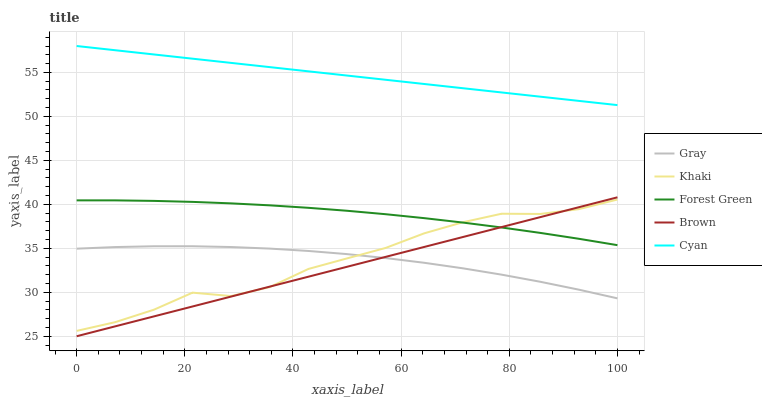Does Forest Green have the minimum area under the curve?
Answer yes or no. No. Does Forest Green have the maximum area under the curve?
Answer yes or no. No. Is Forest Green the smoothest?
Answer yes or no. No. Is Forest Green the roughest?
Answer yes or no. No. Does Forest Green have the lowest value?
Answer yes or no. No. Does Forest Green have the highest value?
Answer yes or no. No. Is Gray less than Forest Green?
Answer yes or no. Yes. Is Cyan greater than Forest Green?
Answer yes or no. Yes. Does Gray intersect Forest Green?
Answer yes or no. No. 